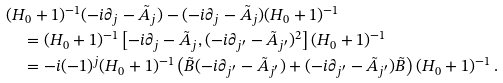Convert formula to latex. <formula><loc_0><loc_0><loc_500><loc_500>& ( H _ { 0 } + 1 ) ^ { - 1 } ( - i \partial _ { j } - \tilde { A } _ { j } ) - ( - i \partial _ { j } - \tilde { A } _ { j } ) ( H _ { 0 } + 1 ) ^ { - 1 } \\ & \quad = ( H _ { 0 } + 1 ) ^ { - 1 } \left [ - i \partial _ { j } - \tilde { A } _ { j } , ( - i \partial _ { j ^ { \prime } } - \tilde { A } _ { j ^ { \prime } } ) ^ { 2 } \right ] ( H _ { 0 } + 1 ) ^ { - 1 } \\ & \quad = - i ( - 1 ) ^ { j } ( H _ { 0 } + 1 ) ^ { - 1 } \left ( \tilde { B } ( - i \partial _ { j ^ { \prime } } - \tilde { A } _ { j ^ { \prime } } ) + ( - i \partial _ { j ^ { \prime } } - \tilde { A } _ { j ^ { \prime } } ) \tilde { B } \right ) ( H _ { 0 } + 1 ) ^ { - 1 } \, .</formula> 